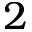Convert formula to latex. <formula><loc_0><loc_0><loc_500><loc_500>2</formula> 